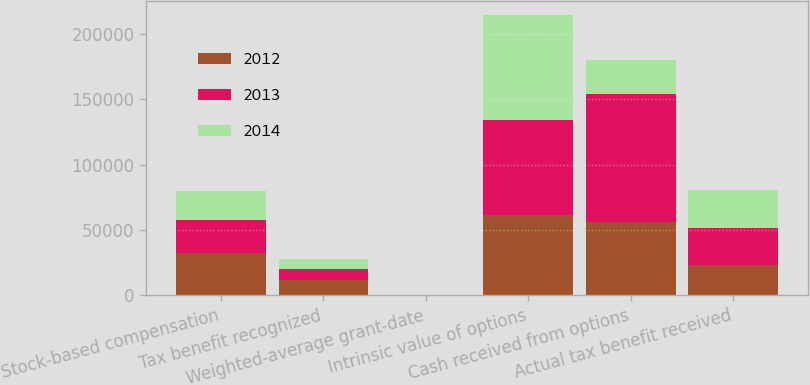<chart> <loc_0><loc_0><loc_500><loc_500><stacked_bar_chart><ecel><fcel>Stock-based compensation<fcel>Tax benefit recognized<fcel>Weighted-average grant-date<fcel>Intrinsic value of options<fcel>Cash received from options<fcel>Actual tax benefit received<nl><fcel>2012<fcel>32203<fcel>11271<fcel>14.77<fcel>61229<fcel>56294<fcel>23232<nl><fcel>2013<fcel>25642<fcel>8975<fcel>12.37<fcel>72793<fcel>97815<fcel>27972<nl><fcel>2014<fcel>21605<fcel>7562<fcel>10.47<fcel>80781<fcel>25642<fcel>29307<nl></chart> 